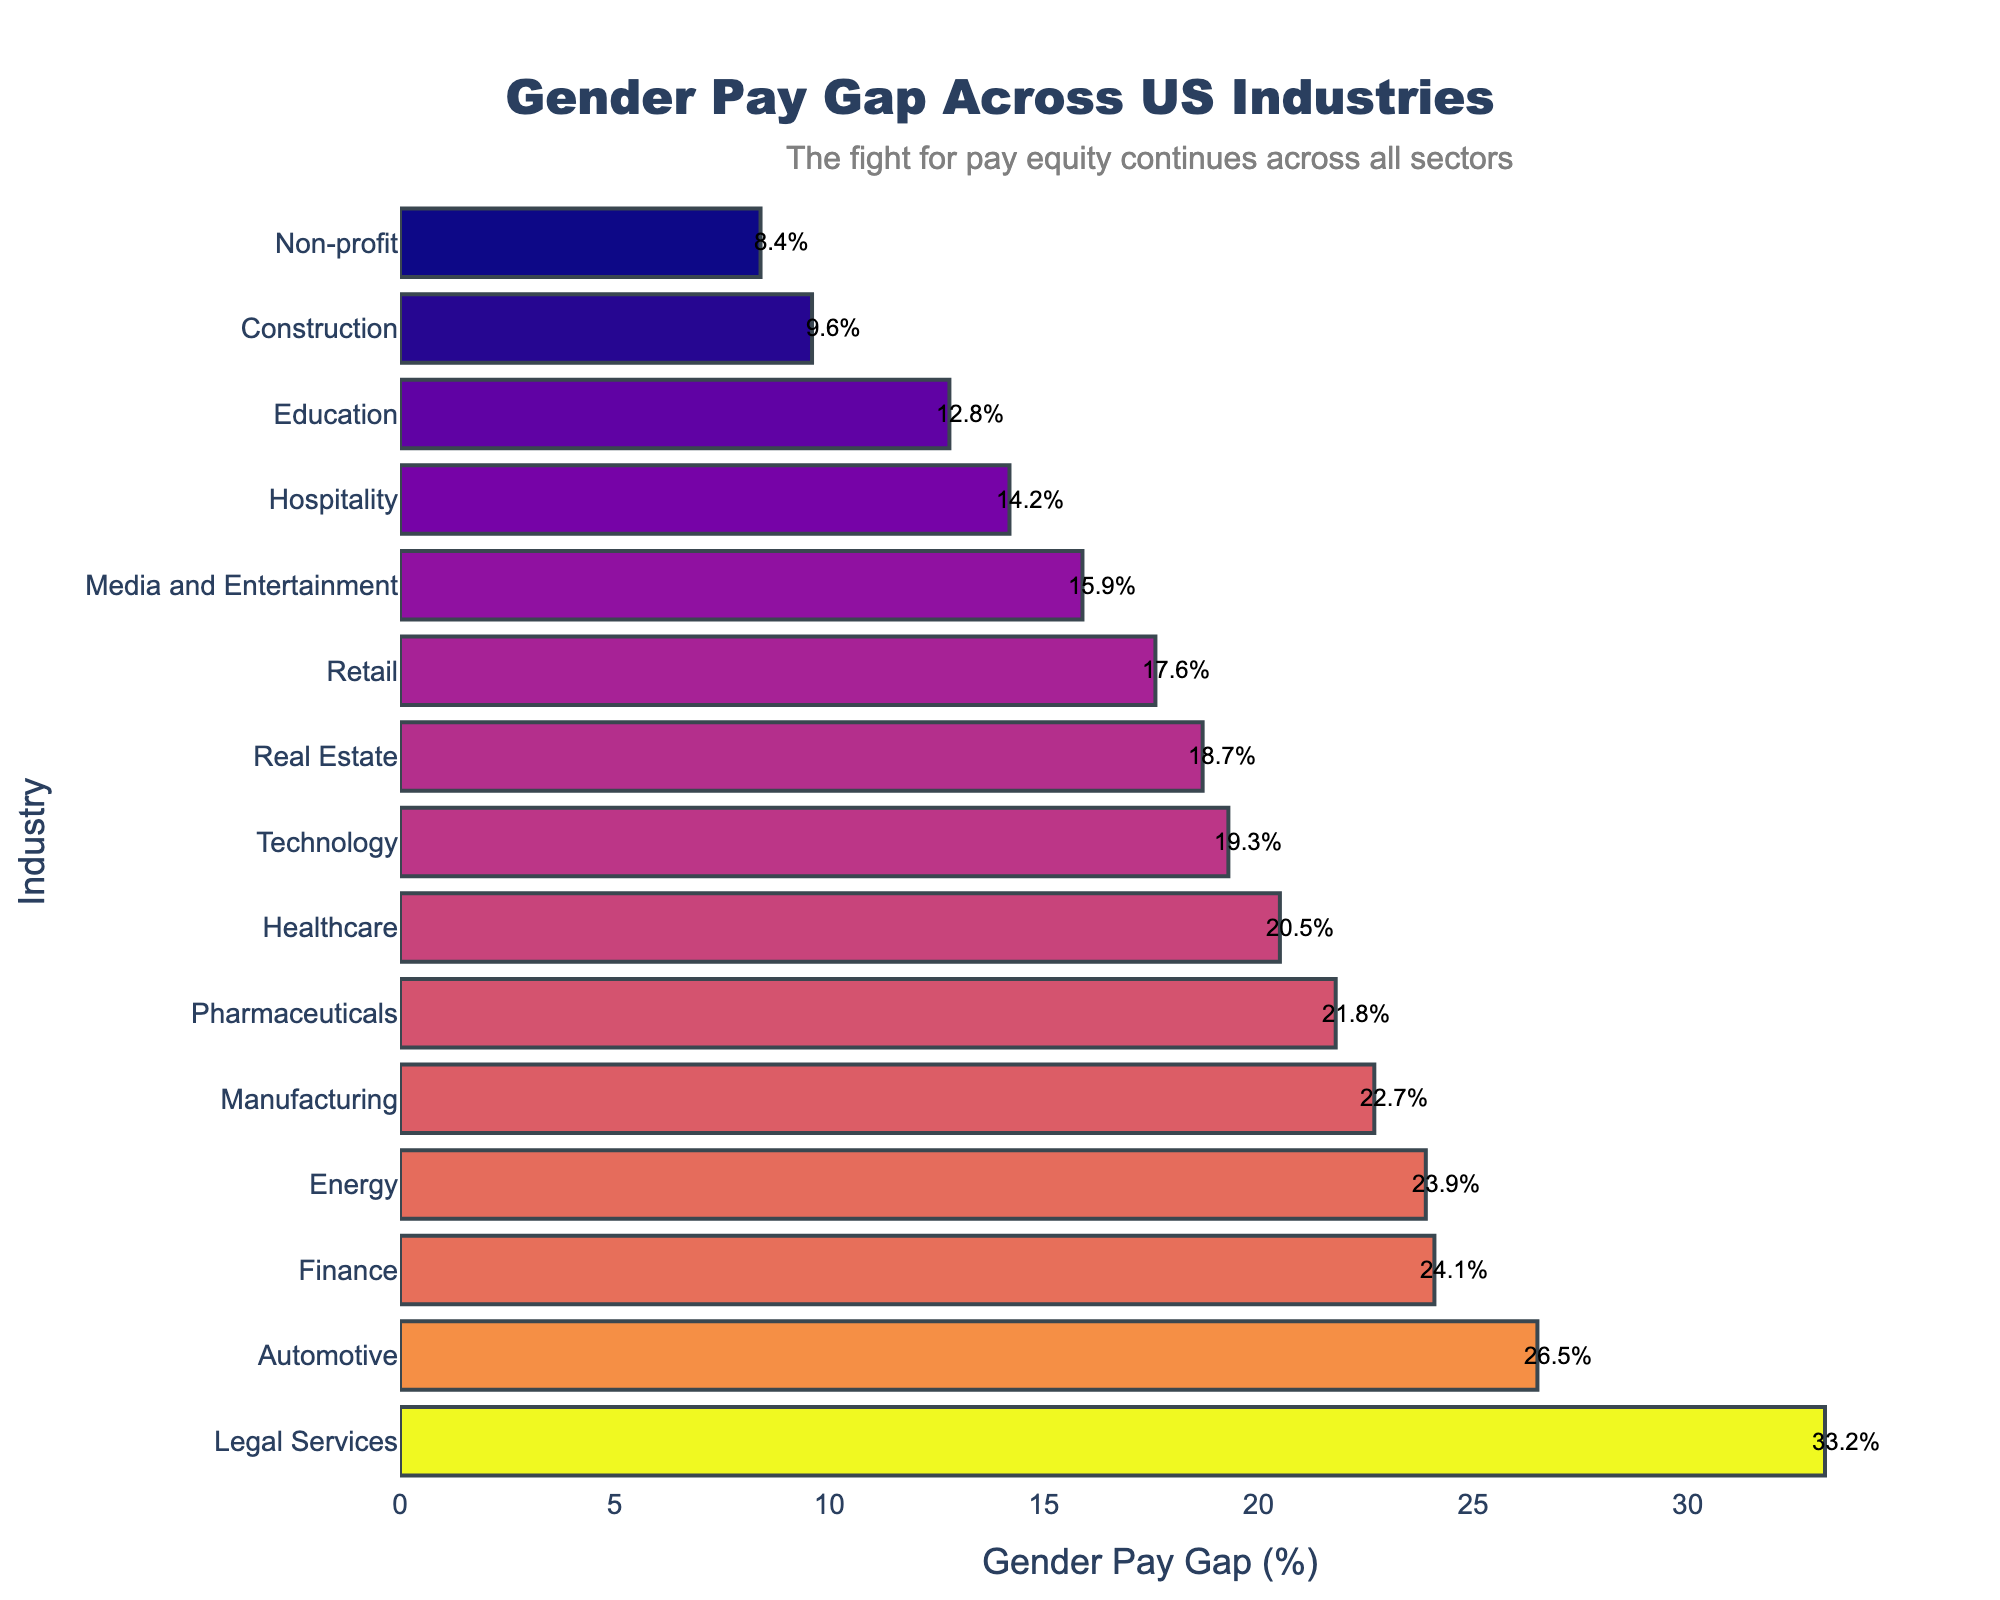Which industry has the highest gender pay gap? The highest gender pay gap can be identified by finding the bar with the greatest length on the chart. The bar for 'Legal Services' is the longest, indicating the highest gender pay gap.
Answer: Legal Services Which industry has the lowest gender pay gap? The industry with the lowest gender pay gap will have the shortest bar on the chart. The shortest bar belongs to 'Non-profit,' showing the lowest gender pay gap.
Answer: Non-profit What is the average gender pay gap across all industries listed? To find the average gender pay gap, sum all the values and divide by the number of industries. Sum = 294.6 and there are 15 industries. \((294.6 / 15) = 19.64\)%.
Answer: 19.64% Which industries have a gender pay gap greater than 20%? Industries with bars extending beyond the 20% marker include 'Healthcare,' 'Technology,' 'Finance,' 'Manufacturing,' 'Legal Services,' 'Pharmaceuticals,' 'Automotive,' and 'Energy.'
Answer: Healthcare, Technology, Finance, Manufacturing, Legal Services, Pharmaceuticals, Automotive, Energy How much greater is the gender pay gap in the Finance industry compared to the Education industry? The gender pay gap in Finance is 24.1% and in Education it is 12.8%. The difference is \(24.1 - 12.8 = 11.3\)%
Answer: 11.3% Are more industries above or below the average gender pay gap? Calculate the average gender pay gap (19.64%), then count how many industries are above and below this value. 8 industries are above, and 7 are below the average.
Answer: More industries above What are the total gender pay gaps for 'Healthcare' and 'Technology' industries combined? Adding the pay gaps for Healthcare (20.5%) and Technology (19.3%) gives \(20.5 + 19.3 = 39.8\)%.
Answer: 39.8% Is the gender pay gap in the Construction industry closer to that of the Real Estate industry or the Retail industry? The gender pay gap for Construction (9.6%) is compared with Real Estate (18.7%) and Retail (17.6%). \((9.6 - 18.7 = 9.1)\) vs. \((9.6 - 17.6 = 8)\). It's closer to Retail by 1.1 percentage points.
Answer: Retail industry What is the median gender pay gap across all industries? To find the median, arrange the pay gaps in ascending order and identify the middle value. The median value of the ordered list (8.4%, 9.6%, 12.8%, 14.2%, 15.9%, 17.6%, 18.7%, 19.3%, 20.5%, 21.8%, 22.7%, 23.9%, 24.1%, 26.5%, 33.2%) is the 8th value, which is 19.3%.
Answer: 19.3% 